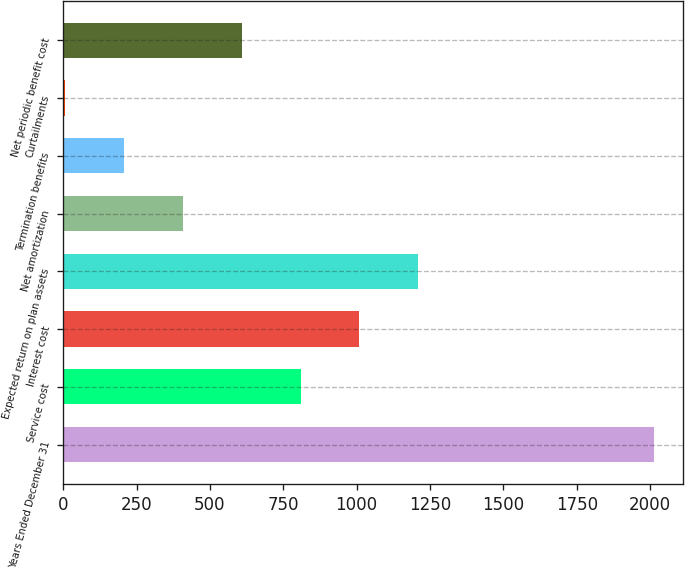<chart> <loc_0><loc_0><loc_500><loc_500><bar_chart><fcel>Years Ended December 31<fcel>Service cost<fcel>Interest cost<fcel>Expected return on plan assets<fcel>Net amortization<fcel>Termination benefits<fcel>Curtailments<fcel>Net periodic benefit cost<nl><fcel>2012<fcel>809<fcel>1009.5<fcel>1210<fcel>408<fcel>207.5<fcel>7<fcel>608.5<nl></chart> 